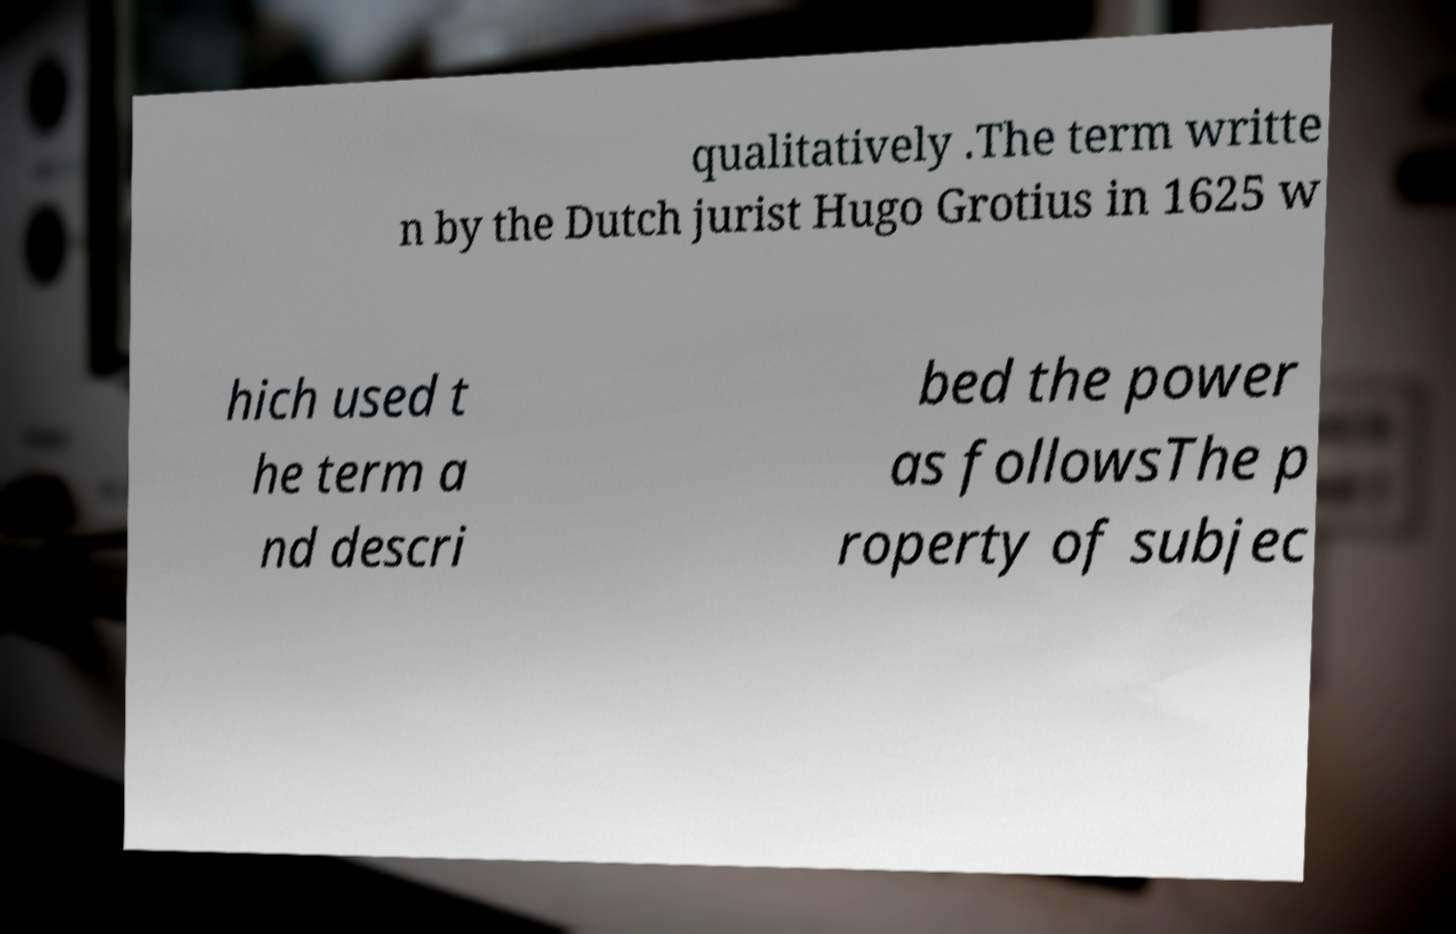Can you accurately transcribe the text from the provided image for me? qualitatively .The term writte n by the Dutch jurist Hugo Grotius in 1625 w hich used t he term a nd descri bed the power as followsThe p roperty of subjec 